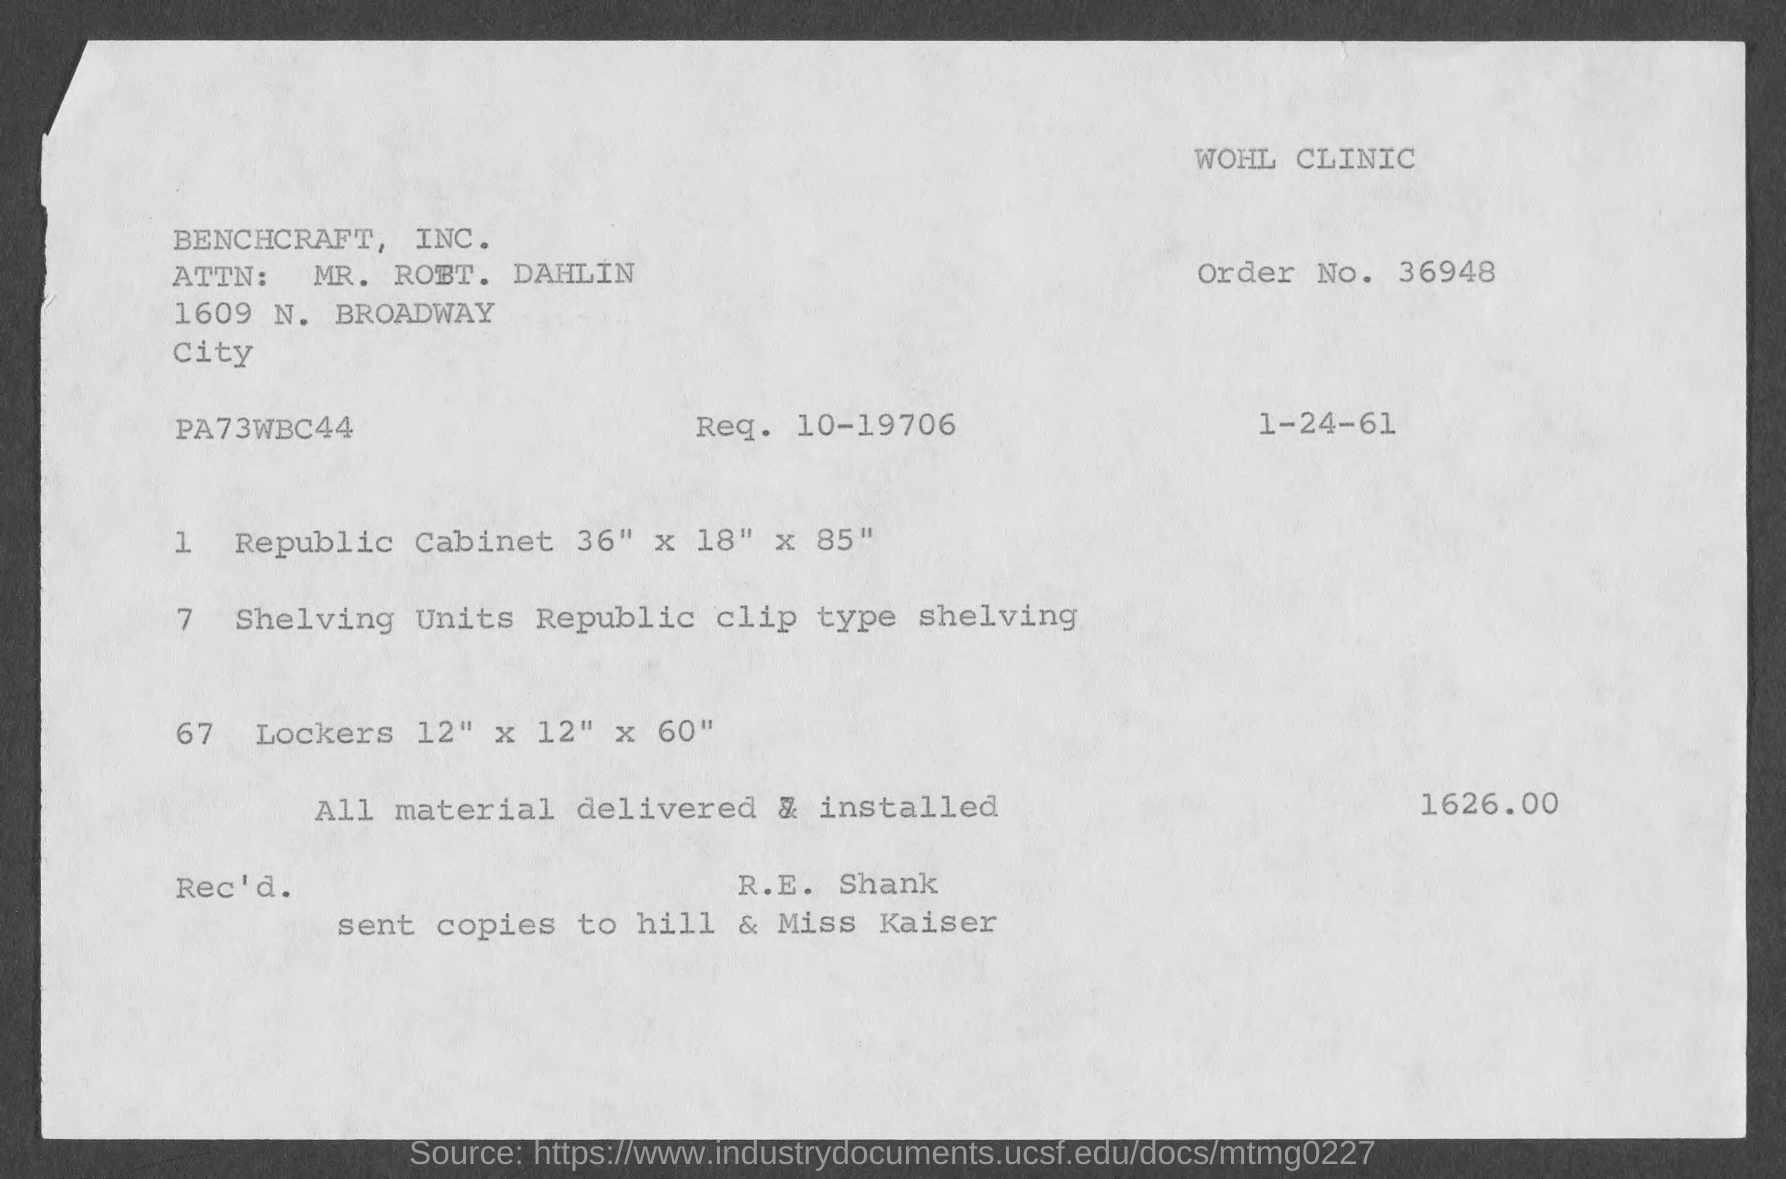Highlight a few significant elements in this photo. The request number indicated on the invoice is 10-19706. The invoice is being raised by Benchcraft, Inc... The total invoice amount is 1626.00. The order number provided on the invoice is 36948. The date mentioned on the invoice is January 1, 1961. 